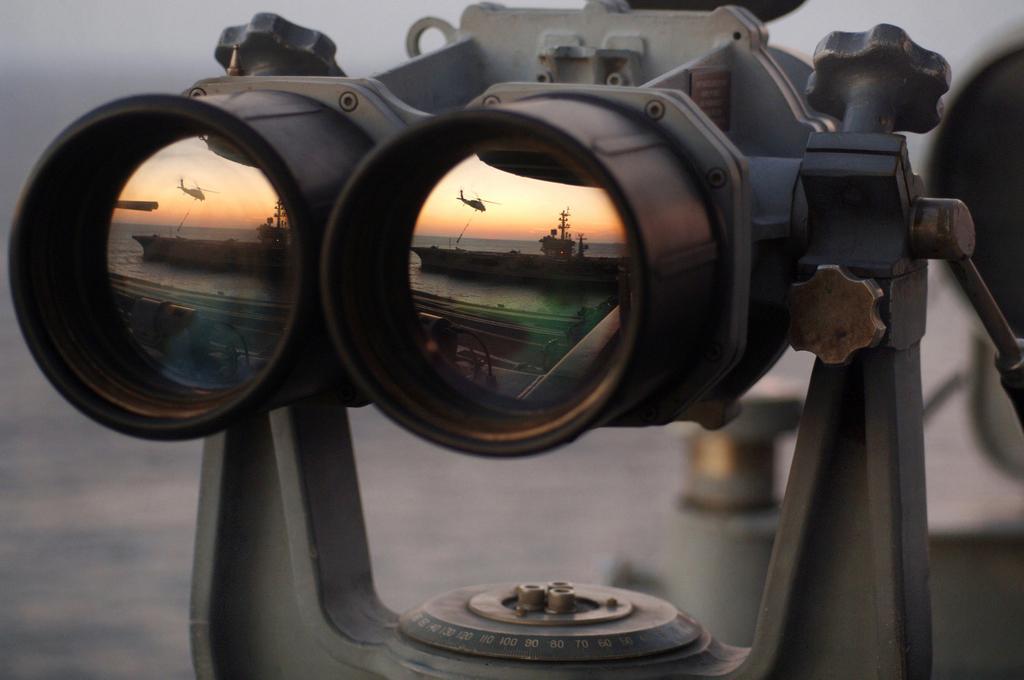Describe this image in one or two sentences. In this image we can see a binoculars. 